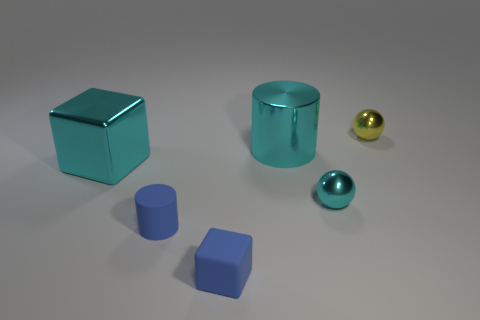Add 2 tiny yellow things. How many objects exist? 8 Subtract all cyan cylinders. How many cylinders are left? 1 Subtract all cylinders. How many objects are left? 4 Subtract all red balls. Subtract all cyan cubes. How many balls are left? 2 Subtract all tiny rubber cylinders. Subtract all big metal cylinders. How many objects are left? 4 Add 6 metal balls. How many metal balls are left? 8 Add 4 cyan cubes. How many cyan cubes exist? 5 Subtract 0 purple spheres. How many objects are left? 6 